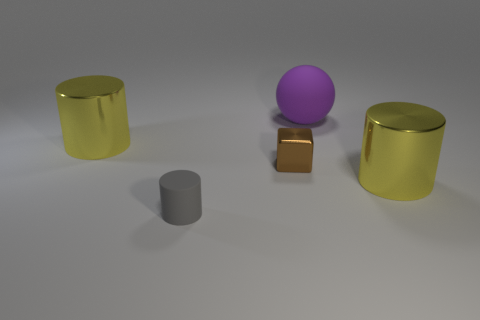Subtract all large yellow metal cylinders. How many cylinders are left? 1 Subtract all blocks. How many objects are left? 4 Subtract all gray cylinders. How many cylinders are left? 2 Subtract all gray spheres. How many yellow cylinders are left? 2 Subtract 2 cylinders. How many cylinders are left? 1 Subtract all small brown matte cylinders. Subtract all large yellow metallic cylinders. How many objects are left? 3 Add 1 spheres. How many spheres are left? 2 Add 2 brown metal things. How many brown metal things exist? 3 Add 2 large green matte cubes. How many objects exist? 7 Subtract 0 gray balls. How many objects are left? 5 